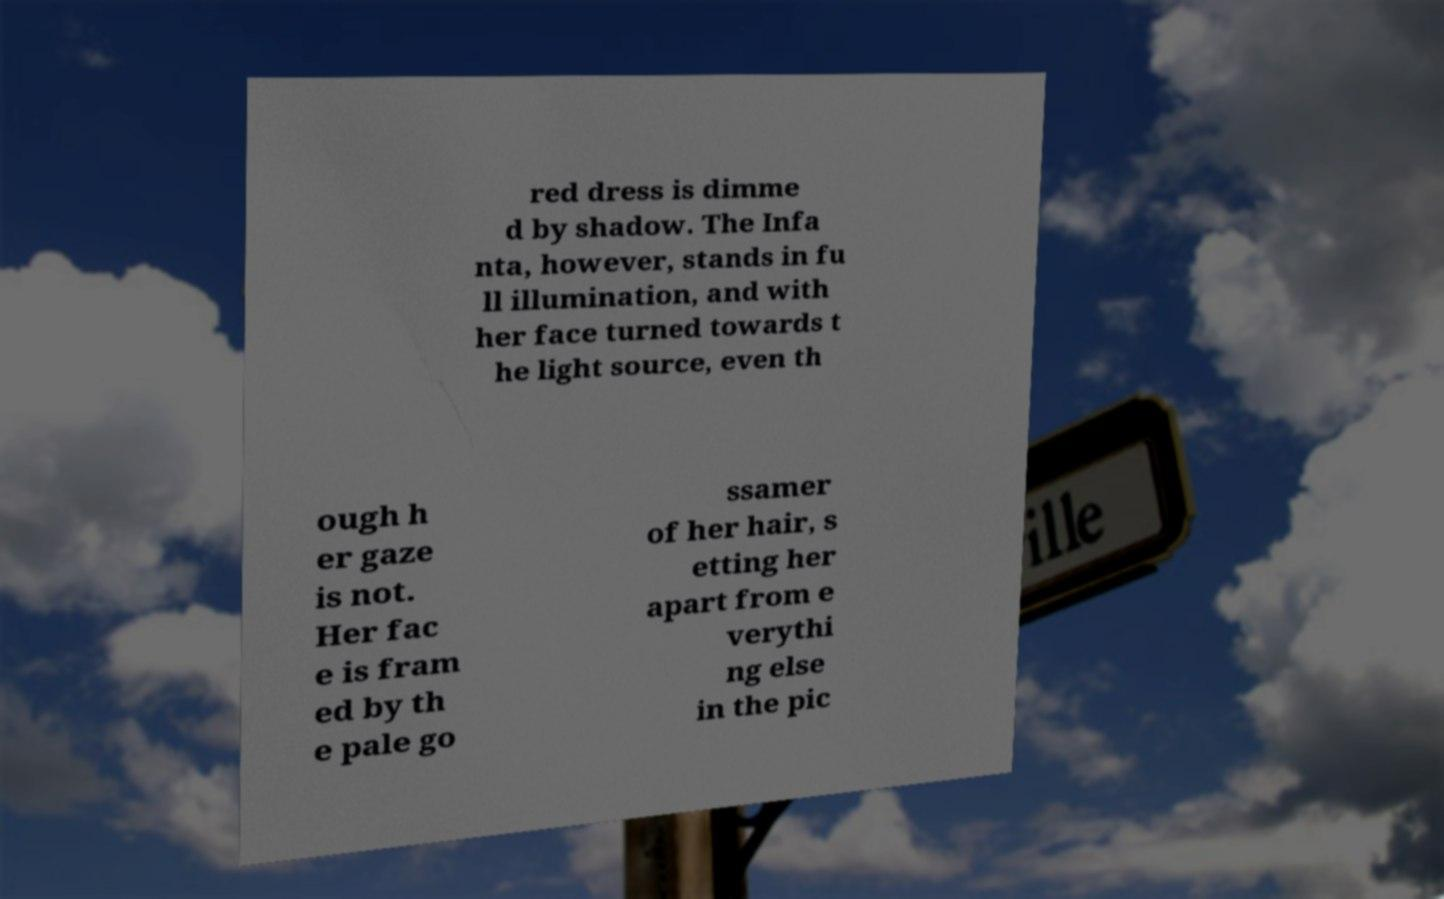Can you read and provide the text displayed in the image?This photo seems to have some interesting text. Can you extract and type it out for me? red dress is dimme d by shadow. The Infa nta, however, stands in fu ll illumination, and with her face turned towards t he light source, even th ough h er gaze is not. Her fac e is fram ed by th e pale go ssamer of her hair, s etting her apart from e verythi ng else in the pic 